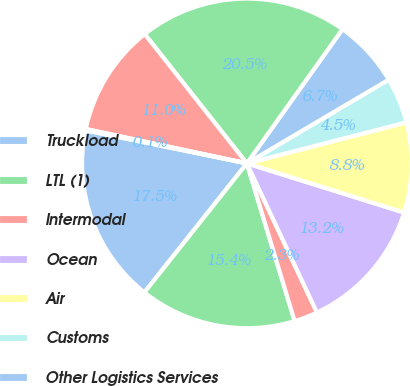Convert chart. <chart><loc_0><loc_0><loc_500><loc_500><pie_chart><fcel>Truckload<fcel>LTL (1)<fcel>Intermodal<fcel>Ocean<fcel>Air<fcel>Customs<fcel>Other Logistics Services<fcel>Total Transportation<fcel>Sourcing<fcel>Payment Services<nl><fcel>17.53%<fcel>15.36%<fcel>2.31%<fcel>13.18%<fcel>8.83%<fcel>4.48%<fcel>6.66%<fcel>20.49%<fcel>11.01%<fcel>0.13%<nl></chart> 